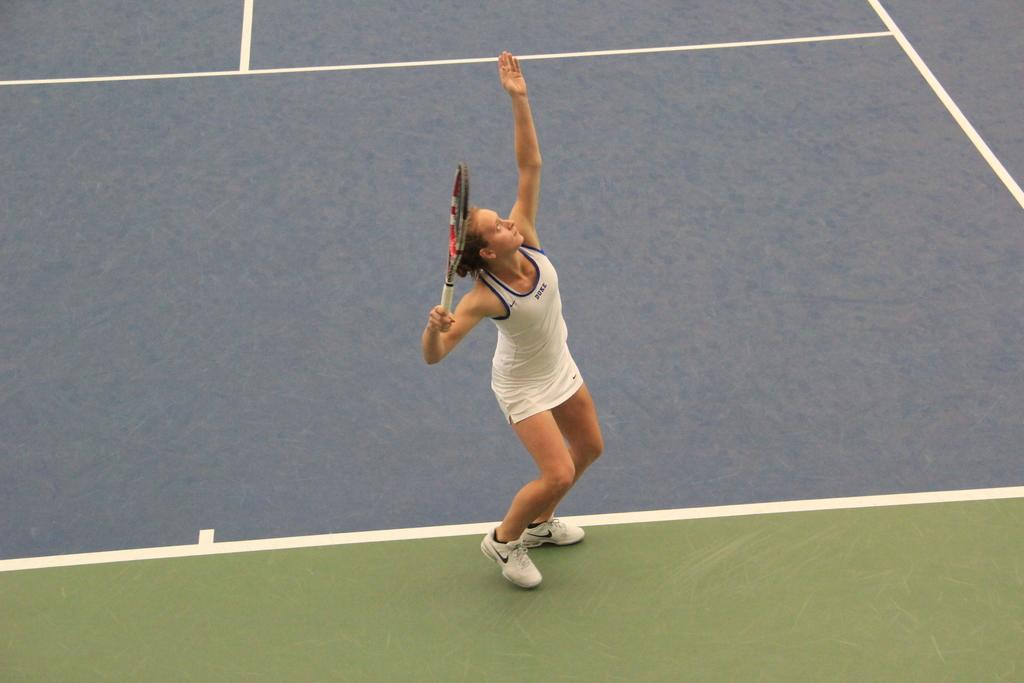What is the location of the image? The image is taken at a tennis ground. Can you describe the main subject in the image? There is a woman standing in the middle of the image. What is the woman holding in the image? The woman is holding a bat. What is the color of the floor in the background of the image? The background of the image includes a floor with a gray color. What type of paste or glue can be seen on the woman's hands in the image? There is no paste or glue visible on the woman's hands in the image. Are there any bushes or shrubs present in the image? No, there are no bushes or shrubs present in the image. 